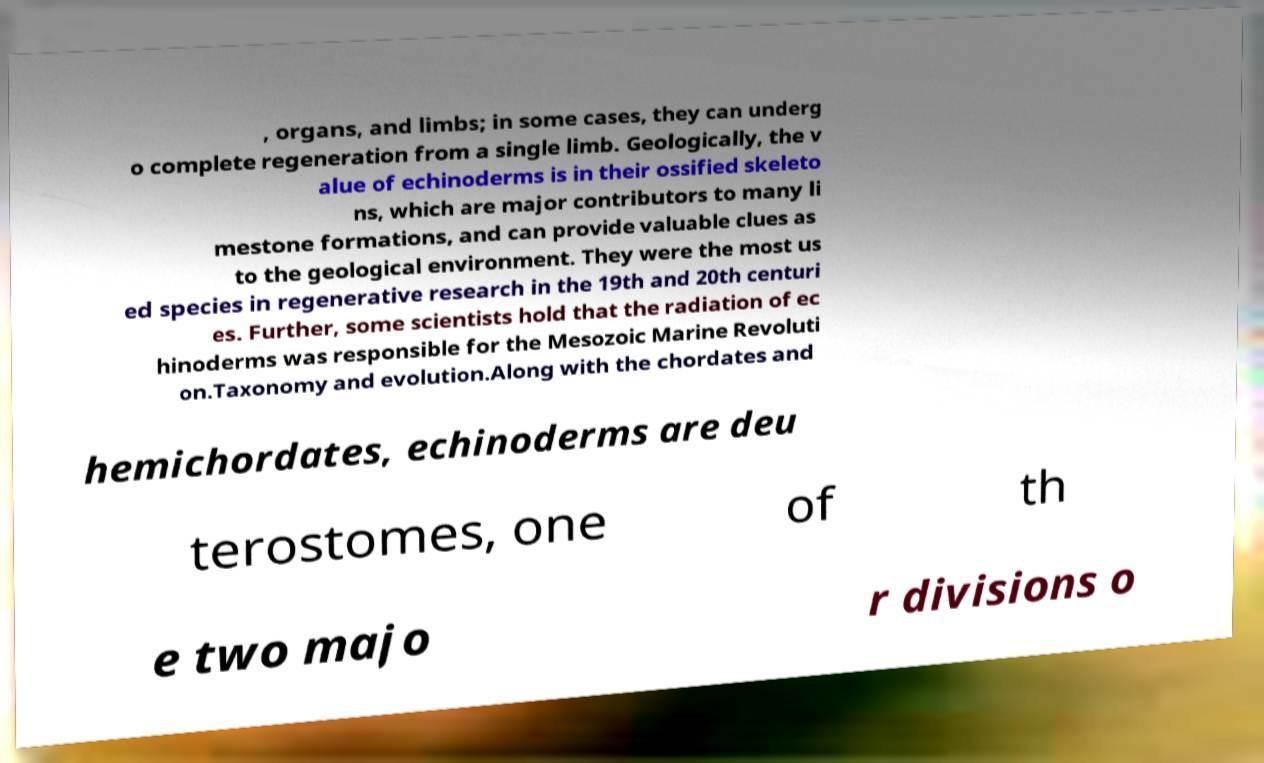There's text embedded in this image that I need extracted. Can you transcribe it verbatim? , organs, and limbs; in some cases, they can underg o complete regeneration from a single limb. Geologically, the v alue of echinoderms is in their ossified skeleto ns, which are major contributors to many li mestone formations, and can provide valuable clues as to the geological environment. They were the most us ed species in regenerative research in the 19th and 20th centuri es. Further, some scientists hold that the radiation of ec hinoderms was responsible for the Mesozoic Marine Revoluti on.Taxonomy and evolution.Along with the chordates and hemichordates, echinoderms are deu terostomes, one of th e two majo r divisions o 